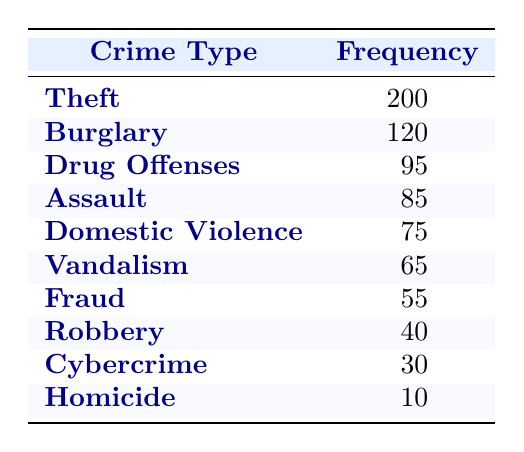What is the most frequently reported crime? By looking at the frequency column in the table, we can see that Theft has the highest frequency at 200 incidents reported.
Answer: Theft How many incidents of Homicide were reported? The table shows that there were 10 incidents of Homicide reported in the last 12 months, as indicated in the frequency column.
Answer: 10 What is the total frequency of Drug Offenses and Domestic Violence? To find the total, we can add the frequencies of Drug Offenses (95) and Domestic Violence (75). 95 + 75 = 170.
Answer: 170 Which crime type has the lowest frequency, and what is that frequency? Looking down the frequency column, Cybercrime has the lowest reported incidents at 30, followed by Robbery at 40. Cybercrime is confirmed to be the lowest.
Answer: Cybercrime, 30 Is the frequency of Assault greater than that of Fraud? The table indicates Assault has a frequency of 85, while Fraud has a frequency of 55. Since 85 is greater than 55, the statement is true.
Answer: Yes What is the difference in frequency between Burglary and Vandalism? The frequency of Burglary is 120 and for Vandalism it is 65. The difference can be calculated as 120 - 65 = 55.
Answer: 55 What are the two crime types with frequencies closest to each other? To determine the closest frequencies, we examine the table. The frequencies for Fraud (55) and Vandalism (65) are closest, with a difference of 10.
Answer: Fraud and Vandalism If we sum the frequencies of Theft, Burglary, and Assault, what would the total be? We find the frequencies of these crimes: Theft (200), Burglary (120), and Assault (85). Summing these gives us 200 + 120 + 85 = 405.
Answer: 405 Which type of crime had more than 75 incidents reported? Reviewing the table, the types of crime with frequencies greater than 75 are Theft (200), Burglary (120), Drug Offenses (95), Assault (85), and Domestic Violence (75).
Answer: Theft, Burglary, Drug Offenses, Assault, Domestic Violence 